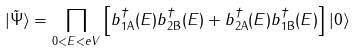Convert formula to latex. <formula><loc_0><loc_0><loc_500><loc_500>| \tilde { \Psi } \rangle = \prod _ { 0 < E < e V } \left [ b ^ { \dagger } _ { 1 \text {A} } ( E ) b ^ { \dagger } _ { 2 \text {B} } ( E ) + b ^ { \dagger } _ { 2 \text {A} } ( E ) b ^ { \dagger } _ { 1 \text {B} } ( E ) \right ] | 0 \rangle</formula> 